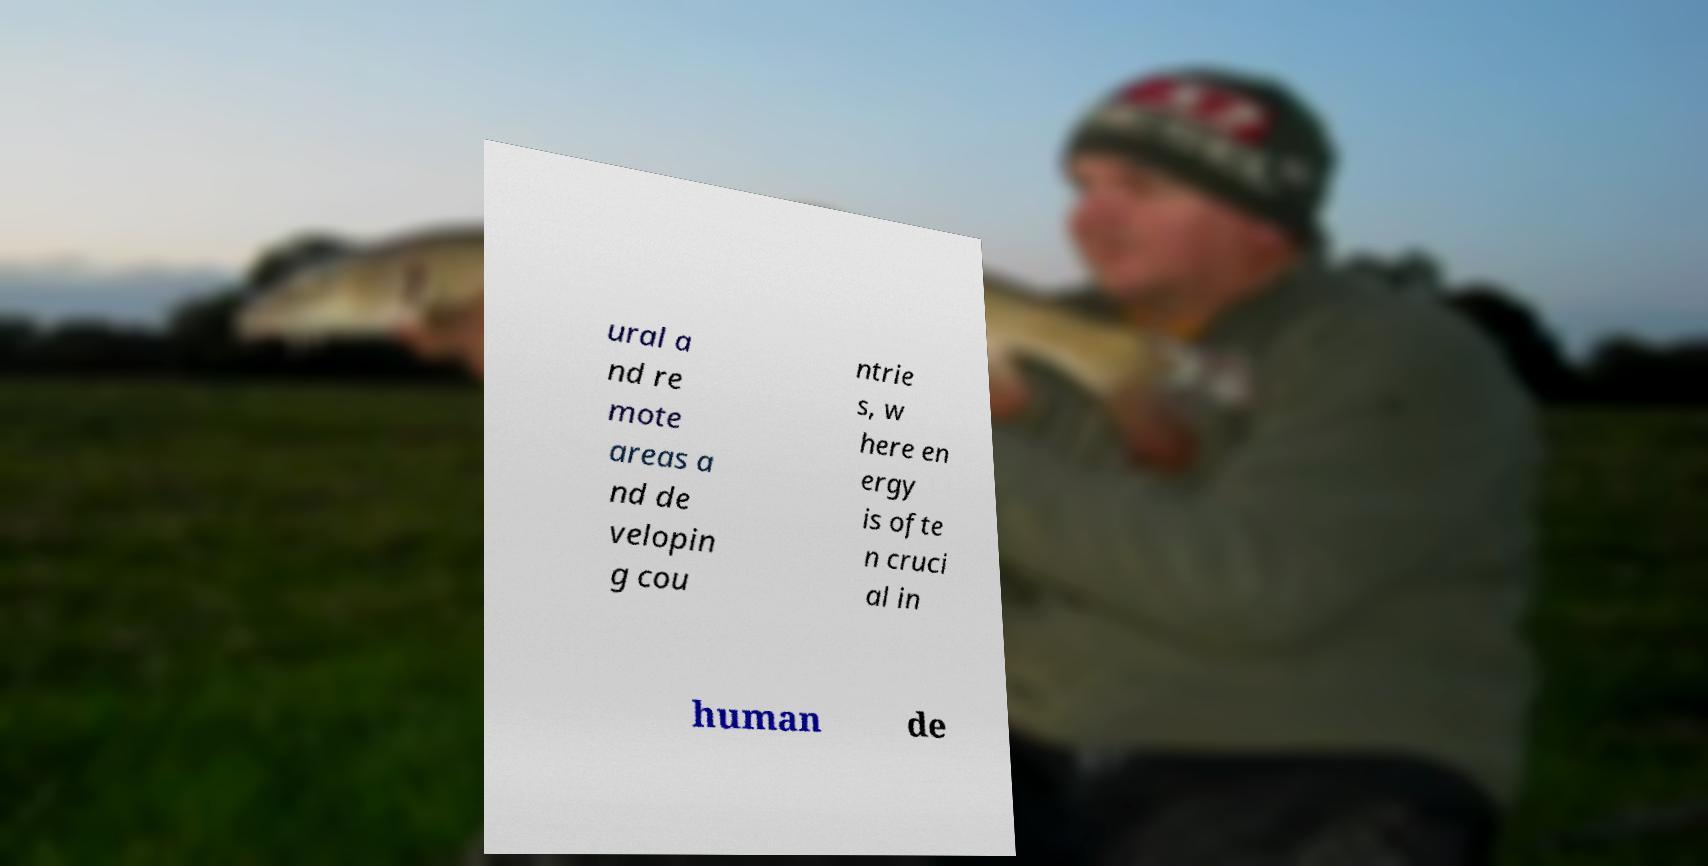Could you assist in decoding the text presented in this image and type it out clearly? ural a nd re mote areas a nd de velopin g cou ntrie s, w here en ergy is ofte n cruci al in human de 